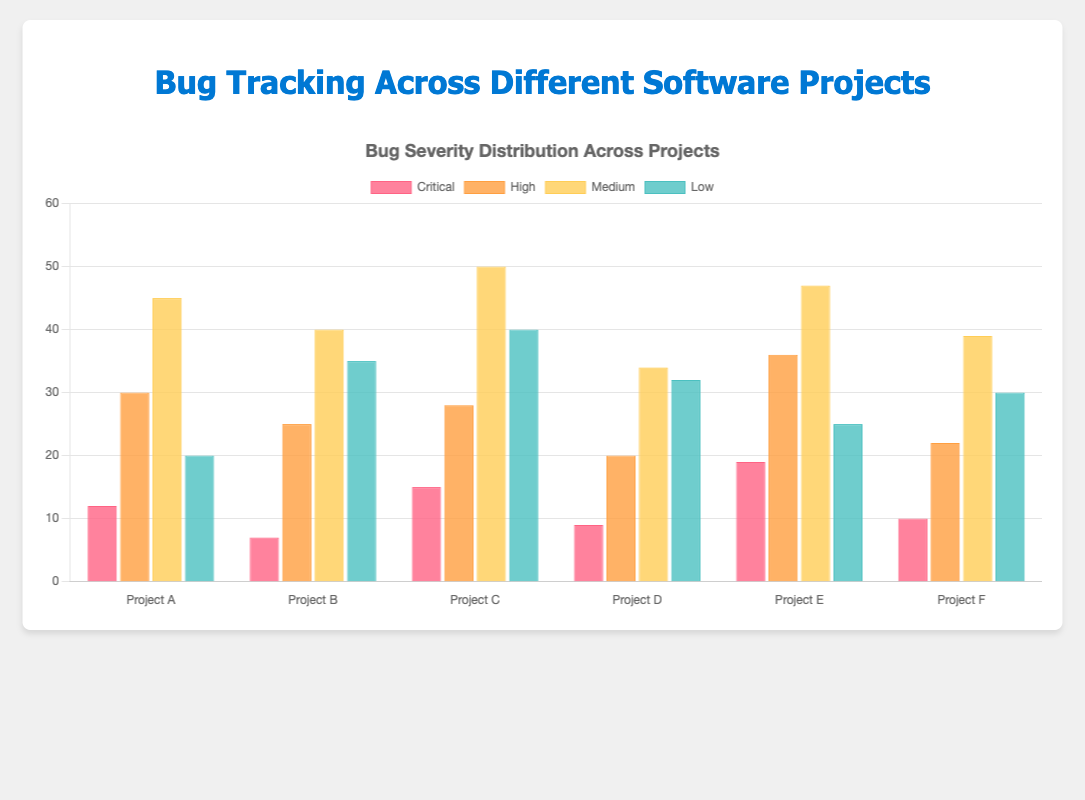Which project has the highest number of critical bugs? By visually inspecting the height of the bars in the "Critical" category, Project E has the highest bar, indicating the most critical bugs.
Answer: Project E How does the number of medium severity bugs in Project B compare to Project D? By comparing the heights of the bars for the "Medium" category in Project B and Project D, Project B has 40 medium severity bugs and Project D has 34.
Answer: Project B has more medium severity bugs What's the total number of bugs for Project A? Sum the numbers of bugs in all severity levels for Project A: 12 + 30 + 45 + 20 = 107.
Answer: 107 Which severity level has the most variability across projects? By visually inspecting the range of bar heights for each severity level, the "Low" severity bars show significant variation.
Answer: Low Is there any project with an equal number of high and critical severity bugs? By comparing the heights of the "Critical" and "High" bars for each project, no project has equal numbers in these categories.
Answer: No Which project has the least number of low severity bugs? By visually comparing the height of the bars in the "Low" category, Project A has the shortest bar with 20 low severity bugs.
Answer: Project A Compare the total number of high severity bugs in Project C and Project F. Sum the high severity bugs for each project: Project C has 28 and Project F has 22 for high severity.
Answer: Project C has more Which project has the highest average number of bugs across all severity levels? Calculate the average for each project and compare: Project A (107/4 = 26.75), Project B (107/4 = 26.75), Project C (133/4 = 33.25), Project D (95/4 = 23.75), Project E (127/4 = 31.75), Project F (101/4 = 25.25). Project C has the highest average.
Answer: Project C If you combine the total number of bugs from Project D and Project F, how does that compare to Project E? Sum the total number of bugs for each project: Project D (95) + Project F (101) = 196. Project E has 127 total bugs. 196 - 127 = 69 more bugs than Project E.
Answer: 69 more bugs Are there any projects where the number of low severity bugs exceeds the number of high severity bugs? By visually comparing the heights of the "Low" and "High" bars, Project B (Low: 35 > High: 25) and Project C (Low: 40 > High: 28) meet this condition.
Answer: Project B and Project C 